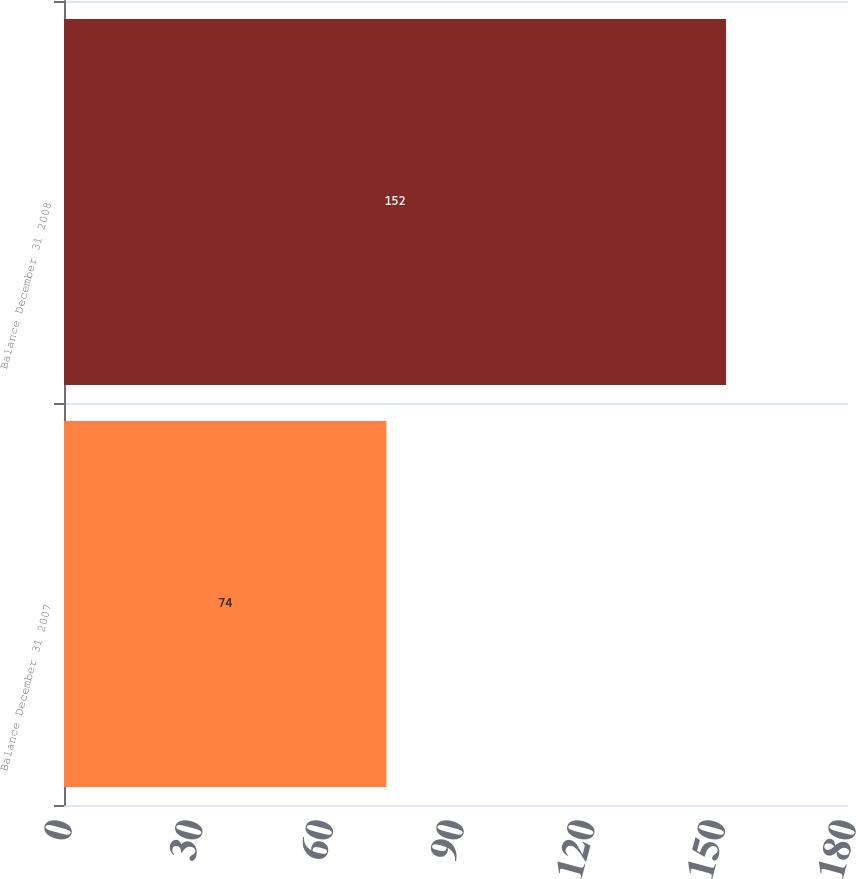<chart> <loc_0><loc_0><loc_500><loc_500><bar_chart><fcel>Balance December 31 2007<fcel>Balance December 31 2008<nl><fcel>74<fcel>152<nl></chart> 